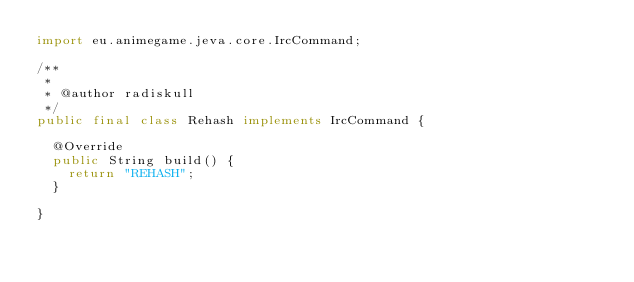Convert code to text. <code><loc_0><loc_0><loc_500><loc_500><_Java_>import eu.animegame.jeva.core.IrcCommand;

/**
 *
 * @author radiskull
 */
public final class Rehash implements IrcCommand {

  @Override
  public String build() {
    return "REHASH";
  }

}
</code> 